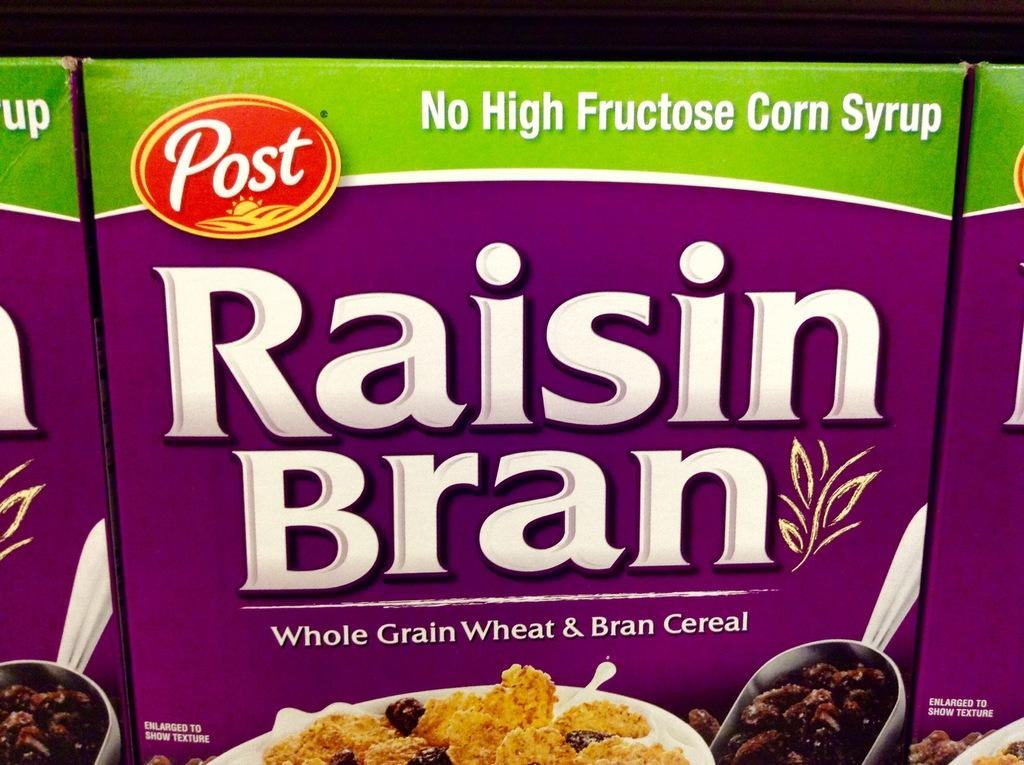What type of cereal packs can be seen in the image? There are whole grain wheat cereal packs and bran cereal packs in the image. What can be found on the cereal packs? The cereal packs have text and images on them. What type of jeans are being worn by the cereal packs in the image? There are no jeans present in the image, as the subject is cereal packs and not people. 